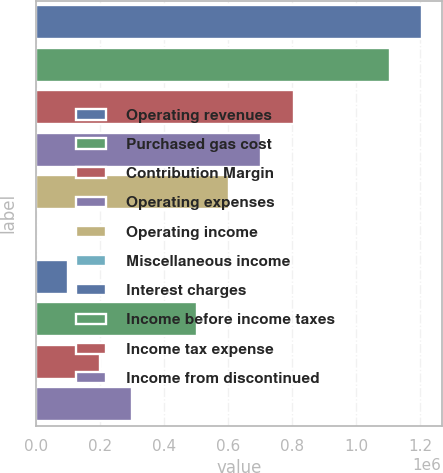Convert chart. <chart><loc_0><loc_0><loc_500><loc_500><bar_chart><fcel>Operating revenues<fcel>Purchased gas cost<fcel>Contribution Margin<fcel>Operating expenses<fcel>Operating income<fcel>Miscellaneous income<fcel>Interest charges<fcel>Income before income taxes<fcel>Income tax expense<fcel>Income from discontinued<nl><fcel>1.20609e+06<fcel>1.10559e+06<fcel>804094<fcel>703596<fcel>603098<fcel>109<fcel>100607<fcel>502600<fcel>201105<fcel>301603<nl></chart> 